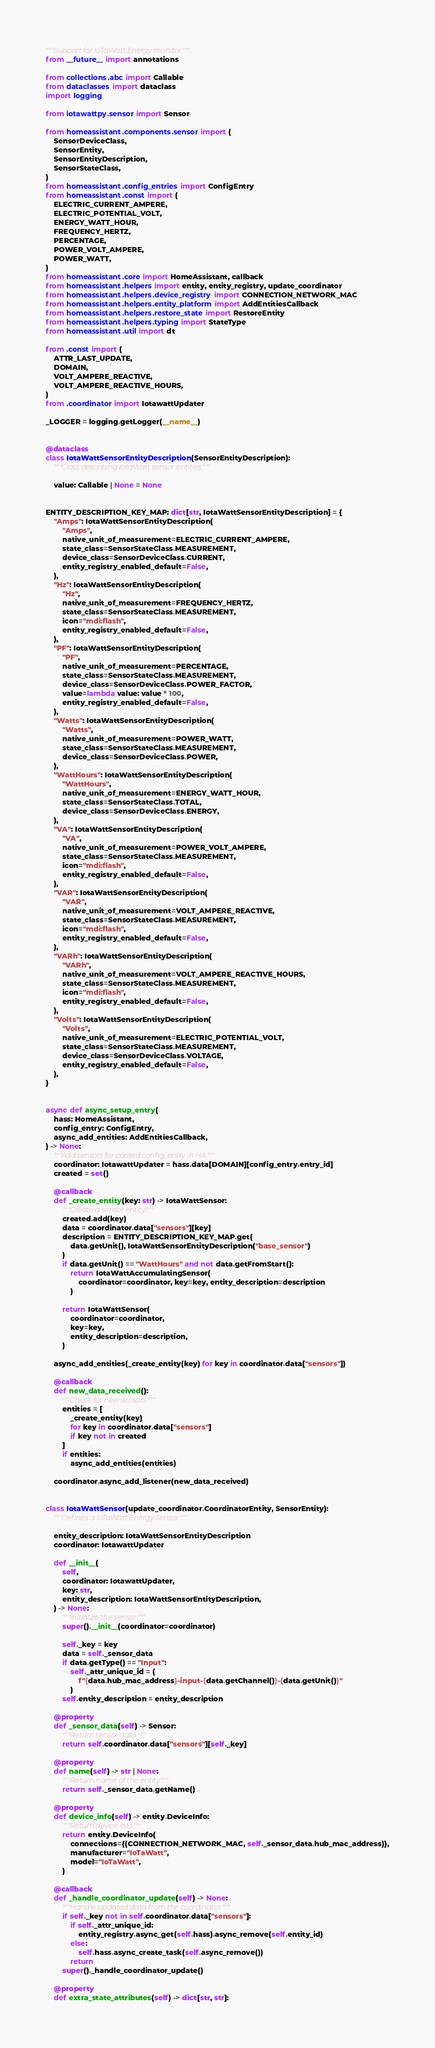Convert code to text. <code><loc_0><loc_0><loc_500><loc_500><_Python_>"""Support for IoTaWatt Energy monitor."""
from __future__ import annotations

from collections.abc import Callable
from dataclasses import dataclass
import logging

from iotawattpy.sensor import Sensor

from homeassistant.components.sensor import (
    SensorDeviceClass,
    SensorEntity,
    SensorEntityDescription,
    SensorStateClass,
)
from homeassistant.config_entries import ConfigEntry
from homeassistant.const import (
    ELECTRIC_CURRENT_AMPERE,
    ELECTRIC_POTENTIAL_VOLT,
    ENERGY_WATT_HOUR,
    FREQUENCY_HERTZ,
    PERCENTAGE,
    POWER_VOLT_AMPERE,
    POWER_WATT,
)
from homeassistant.core import HomeAssistant, callback
from homeassistant.helpers import entity, entity_registry, update_coordinator
from homeassistant.helpers.device_registry import CONNECTION_NETWORK_MAC
from homeassistant.helpers.entity_platform import AddEntitiesCallback
from homeassistant.helpers.restore_state import RestoreEntity
from homeassistant.helpers.typing import StateType
from homeassistant.util import dt

from .const import (
    ATTR_LAST_UPDATE,
    DOMAIN,
    VOLT_AMPERE_REACTIVE,
    VOLT_AMPERE_REACTIVE_HOURS,
)
from .coordinator import IotawattUpdater

_LOGGER = logging.getLogger(__name__)


@dataclass
class IotaWattSensorEntityDescription(SensorEntityDescription):
    """Class describing IotaWatt sensor entities."""

    value: Callable | None = None


ENTITY_DESCRIPTION_KEY_MAP: dict[str, IotaWattSensorEntityDescription] = {
    "Amps": IotaWattSensorEntityDescription(
        "Amps",
        native_unit_of_measurement=ELECTRIC_CURRENT_AMPERE,
        state_class=SensorStateClass.MEASUREMENT,
        device_class=SensorDeviceClass.CURRENT,
        entity_registry_enabled_default=False,
    ),
    "Hz": IotaWattSensorEntityDescription(
        "Hz",
        native_unit_of_measurement=FREQUENCY_HERTZ,
        state_class=SensorStateClass.MEASUREMENT,
        icon="mdi:flash",
        entity_registry_enabled_default=False,
    ),
    "PF": IotaWattSensorEntityDescription(
        "PF",
        native_unit_of_measurement=PERCENTAGE,
        state_class=SensorStateClass.MEASUREMENT,
        device_class=SensorDeviceClass.POWER_FACTOR,
        value=lambda value: value * 100,
        entity_registry_enabled_default=False,
    ),
    "Watts": IotaWattSensorEntityDescription(
        "Watts",
        native_unit_of_measurement=POWER_WATT,
        state_class=SensorStateClass.MEASUREMENT,
        device_class=SensorDeviceClass.POWER,
    ),
    "WattHours": IotaWattSensorEntityDescription(
        "WattHours",
        native_unit_of_measurement=ENERGY_WATT_HOUR,
        state_class=SensorStateClass.TOTAL,
        device_class=SensorDeviceClass.ENERGY,
    ),
    "VA": IotaWattSensorEntityDescription(
        "VA",
        native_unit_of_measurement=POWER_VOLT_AMPERE,
        state_class=SensorStateClass.MEASUREMENT,
        icon="mdi:flash",
        entity_registry_enabled_default=False,
    ),
    "VAR": IotaWattSensorEntityDescription(
        "VAR",
        native_unit_of_measurement=VOLT_AMPERE_REACTIVE,
        state_class=SensorStateClass.MEASUREMENT,
        icon="mdi:flash",
        entity_registry_enabled_default=False,
    ),
    "VARh": IotaWattSensorEntityDescription(
        "VARh",
        native_unit_of_measurement=VOLT_AMPERE_REACTIVE_HOURS,
        state_class=SensorStateClass.MEASUREMENT,
        icon="mdi:flash",
        entity_registry_enabled_default=False,
    ),
    "Volts": IotaWattSensorEntityDescription(
        "Volts",
        native_unit_of_measurement=ELECTRIC_POTENTIAL_VOLT,
        state_class=SensorStateClass.MEASUREMENT,
        device_class=SensorDeviceClass.VOLTAGE,
        entity_registry_enabled_default=False,
    ),
}


async def async_setup_entry(
    hass: HomeAssistant,
    config_entry: ConfigEntry,
    async_add_entities: AddEntitiesCallback,
) -> None:
    """Add sensors for passed config_entry in HA."""
    coordinator: IotawattUpdater = hass.data[DOMAIN][config_entry.entry_id]
    created = set()

    @callback
    def _create_entity(key: str) -> IotaWattSensor:
        """Create a sensor entity."""
        created.add(key)
        data = coordinator.data["sensors"][key]
        description = ENTITY_DESCRIPTION_KEY_MAP.get(
            data.getUnit(), IotaWattSensorEntityDescription("base_sensor")
        )
        if data.getUnit() == "WattHours" and not data.getFromStart():
            return IotaWattAccumulatingSensor(
                coordinator=coordinator, key=key, entity_description=description
            )

        return IotaWattSensor(
            coordinator=coordinator,
            key=key,
            entity_description=description,
        )

    async_add_entities(_create_entity(key) for key in coordinator.data["sensors"])

    @callback
    def new_data_received():
        """Check for new sensors."""
        entities = [
            _create_entity(key)
            for key in coordinator.data["sensors"]
            if key not in created
        ]
        if entities:
            async_add_entities(entities)

    coordinator.async_add_listener(new_data_received)


class IotaWattSensor(update_coordinator.CoordinatorEntity, SensorEntity):
    """Defines a IoTaWatt Energy Sensor."""

    entity_description: IotaWattSensorEntityDescription
    coordinator: IotawattUpdater

    def __init__(
        self,
        coordinator: IotawattUpdater,
        key: str,
        entity_description: IotaWattSensorEntityDescription,
    ) -> None:
        """Initialize the sensor."""
        super().__init__(coordinator=coordinator)

        self._key = key
        data = self._sensor_data
        if data.getType() == "Input":
            self._attr_unique_id = (
                f"{data.hub_mac_address}-input-{data.getChannel()}-{data.getUnit()}"
            )
        self.entity_description = entity_description

    @property
    def _sensor_data(self) -> Sensor:
        """Return sensor data."""
        return self.coordinator.data["sensors"][self._key]

    @property
    def name(self) -> str | None:
        """Return name of the entity."""
        return self._sensor_data.getName()

    @property
    def device_info(self) -> entity.DeviceInfo:
        """Return device info."""
        return entity.DeviceInfo(
            connections={(CONNECTION_NETWORK_MAC, self._sensor_data.hub_mac_address)},
            manufacturer="IoTaWatt",
            model="IoTaWatt",
        )

    @callback
    def _handle_coordinator_update(self) -> None:
        """Handle updated data from the coordinator."""
        if self._key not in self.coordinator.data["sensors"]:
            if self._attr_unique_id:
                entity_registry.async_get(self.hass).async_remove(self.entity_id)
            else:
                self.hass.async_create_task(self.async_remove())
            return
        super()._handle_coordinator_update()

    @property
    def extra_state_attributes(self) -> dict[str, str]:</code> 